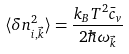<formula> <loc_0><loc_0><loc_500><loc_500>\langle \delta n _ { i , \vec { k } } ^ { 2 } \rangle = \frac { k _ { B } T ^ { 2 } \bar { c } _ { v } } { 2 \hbar { \omega } _ { \vec { k } } }</formula> 